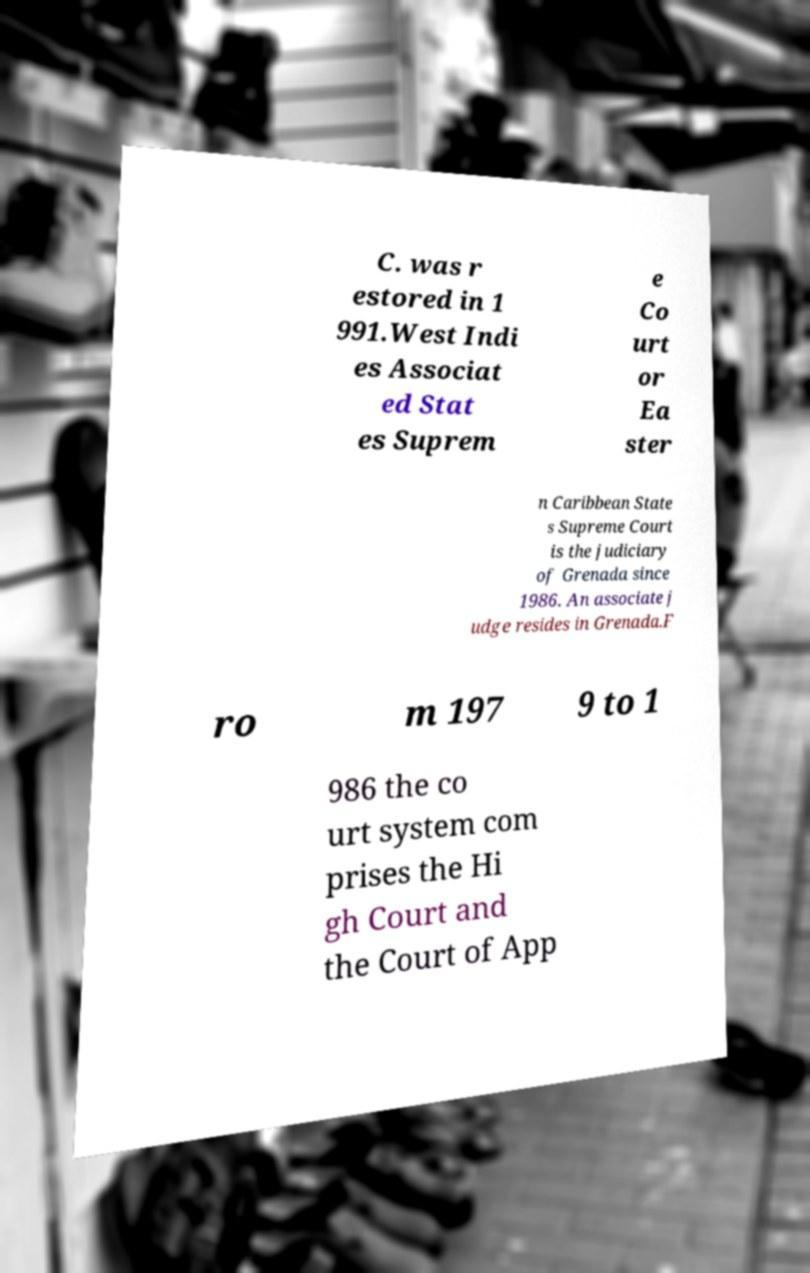Could you assist in decoding the text presented in this image and type it out clearly? C. was r estored in 1 991.West Indi es Associat ed Stat es Suprem e Co urt or Ea ster n Caribbean State s Supreme Court is the judiciary of Grenada since 1986. An associate j udge resides in Grenada.F ro m 197 9 to 1 986 the co urt system com prises the Hi gh Court and the Court of App 